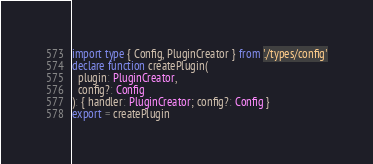Convert code to text. <code><loc_0><loc_0><loc_500><loc_500><_TypeScript_>import type { Config, PluginCreator } from './types/config'
declare function createPlugin(
  plugin: PluginCreator,
  config?: Config
): { handler: PluginCreator; config?: Config }
export = createPlugin
</code> 